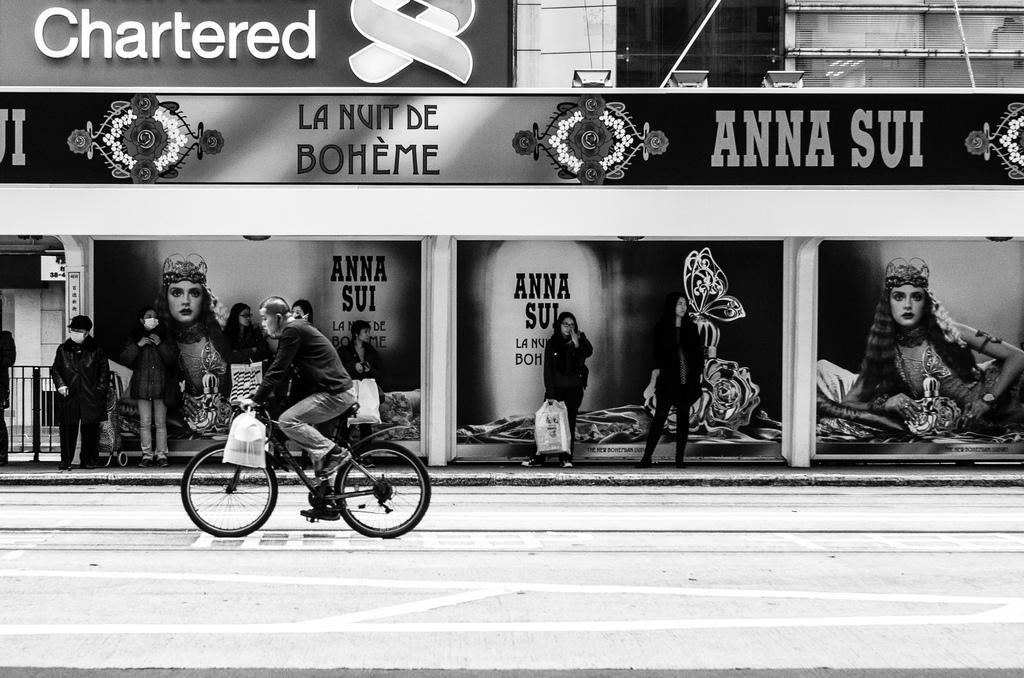What is the main activity of the person in the image? There is a person riding a bicycle in the image. What can be seen in the background of the image? There are people standing under a shed in the image. Can you describe the shed in the image? The shed has some boards and some lights. What is the taste of the cannon in the image? There is no cannon present in the image, so it is not possible to determine its taste. 